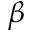Convert formula to latex. <formula><loc_0><loc_0><loc_500><loc_500>\beta</formula> 